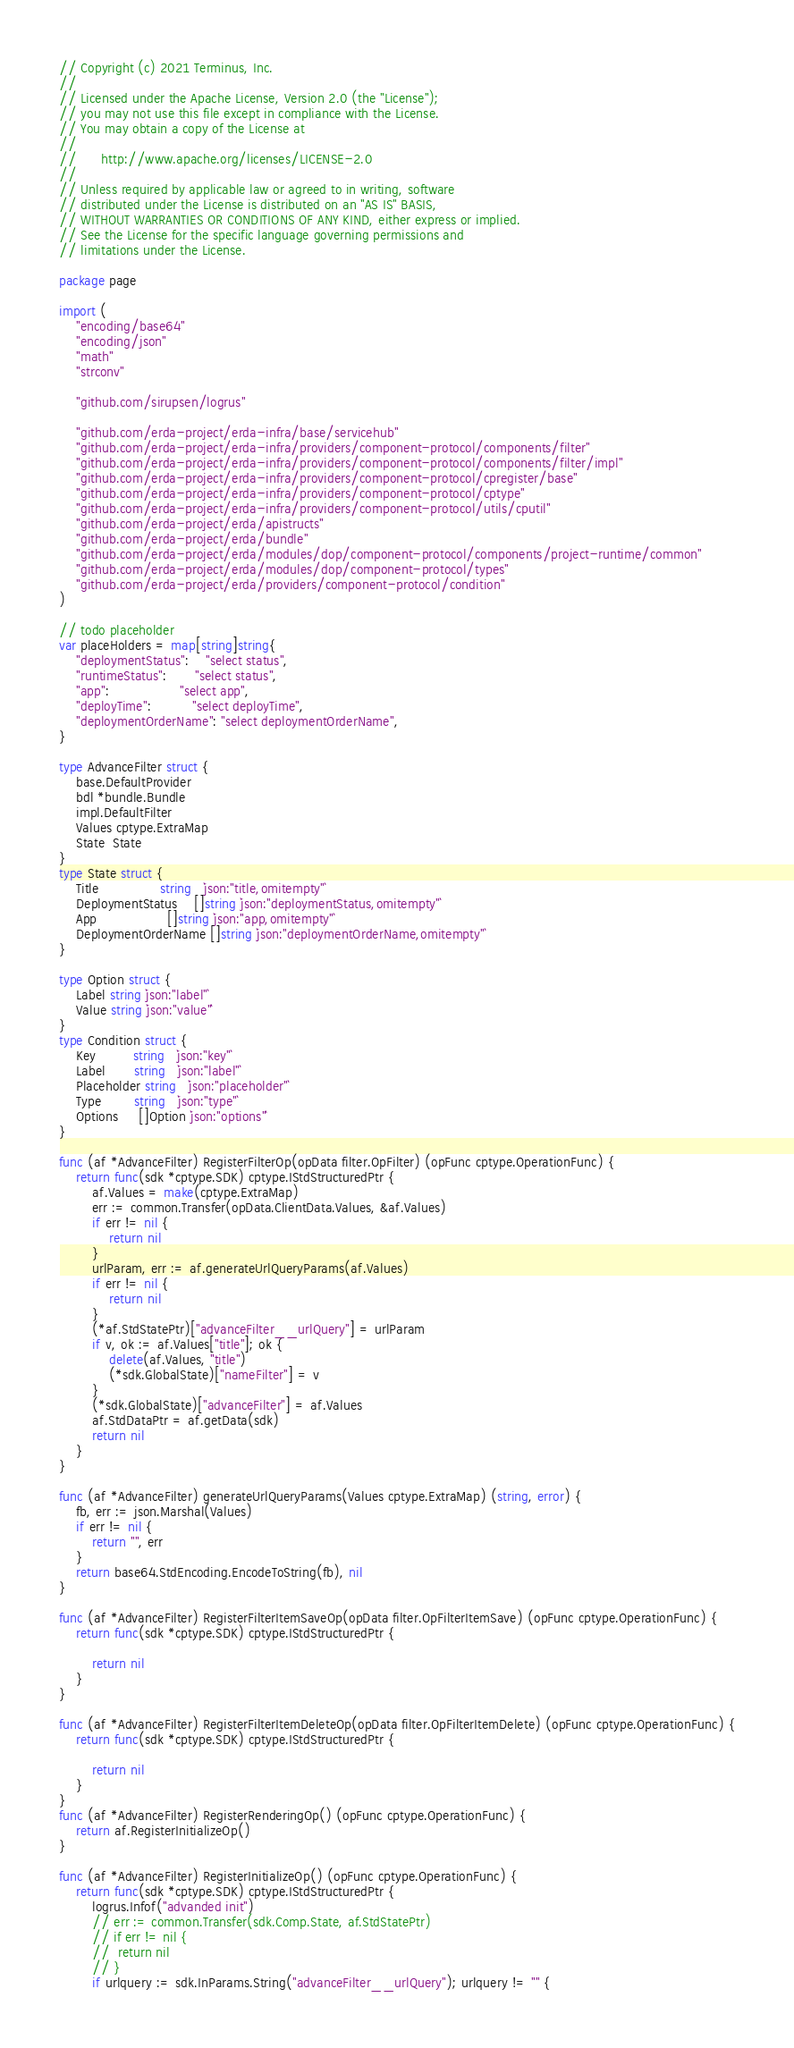<code> <loc_0><loc_0><loc_500><loc_500><_Go_>// Copyright (c) 2021 Terminus, Inc.
//
// Licensed under the Apache License, Version 2.0 (the "License");
// you may not use this file except in compliance with the License.
// You may obtain a copy of the License at
//
//      http://www.apache.org/licenses/LICENSE-2.0
//
// Unless required by applicable law or agreed to in writing, software
// distributed under the License is distributed on an "AS IS" BASIS,
// WITHOUT WARRANTIES OR CONDITIONS OF ANY KIND, either express or implied.
// See the License for the specific language governing permissions and
// limitations under the License.

package page

import (
	"encoding/base64"
	"encoding/json"
	"math"
	"strconv"

	"github.com/sirupsen/logrus"

	"github.com/erda-project/erda-infra/base/servicehub"
	"github.com/erda-project/erda-infra/providers/component-protocol/components/filter"
	"github.com/erda-project/erda-infra/providers/component-protocol/components/filter/impl"
	"github.com/erda-project/erda-infra/providers/component-protocol/cpregister/base"
	"github.com/erda-project/erda-infra/providers/component-protocol/cptype"
	"github.com/erda-project/erda-infra/providers/component-protocol/utils/cputil"
	"github.com/erda-project/erda/apistructs"
	"github.com/erda-project/erda/bundle"
	"github.com/erda-project/erda/modules/dop/component-protocol/components/project-runtime/common"
	"github.com/erda-project/erda/modules/dop/component-protocol/types"
	"github.com/erda-project/erda/providers/component-protocol/condition"
)

// todo placeholder
var placeHolders = map[string]string{
	"deploymentStatus":    "select status",
	"runtimeStatus":       "select status",
	"app":                 "select app",
	"deployTime":          "select deployTime",
	"deploymentOrderName": "select deploymentOrderName",
}

type AdvanceFilter struct {
	base.DefaultProvider
	bdl *bundle.Bundle
	impl.DefaultFilter
	Values cptype.ExtraMap
	State  State
}
type State struct {
	Title               string   `json:"title,omitempty"`
	DeploymentStatus    []string `json:"deploymentStatus,omitempty"`
	App                 []string `json:"app,omitempty"`
	DeploymentOrderName []string `json:"deploymentOrderName,omitempty"`
}

type Option struct {
	Label string `json:"label"`
	Value string `json:"value"`
}
type Condition struct {
	Key         string   `json:"key"`
	Label       string   `json:"label"`
	Placeholder string   `json:"placeholder"`
	Type        string   `json:"type"`
	Options     []Option `json:"options"`
}

func (af *AdvanceFilter) RegisterFilterOp(opData filter.OpFilter) (opFunc cptype.OperationFunc) {
	return func(sdk *cptype.SDK) cptype.IStdStructuredPtr {
		af.Values = make(cptype.ExtraMap)
		err := common.Transfer(opData.ClientData.Values, &af.Values)
		if err != nil {
			return nil
		}
		urlParam, err := af.generateUrlQueryParams(af.Values)
		if err != nil {
			return nil
		}
		(*af.StdStatePtr)["advanceFilter__urlQuery"] = urlParam
		if v, ok := af.Values["title"]; ok {
			delete(af.Values, "title")
			(*sdk.GlobalState)["nameFilter"] = v
		}
		(*sdk.GlobalState)["advanceFilter"] = af.Values
		af.StdDataPtr = af.getData(sdk)
		return nil
	}
}

func (af *AdvanceFilter) generateUrlQueryParams(Values cptype.ExtraMap) (string, error) {
	fb, err := json.Marshal(Values)
	if err != nil {
		return "", err
	}
	return base64.StdEncoding.EncodeToString(fb), nil
}

func (af *AdvanceFilter) RegisterFilterItemSaveOp(opData filter.OpFilterItemSave) (opFunc cptype.OperationFunc) {
	return func(sdk *cptype.SDK) cptype.IStdStructuredPtr {

		return nil
	}
}

func (af *AdvanceFilter) RegisterFilterItemDeleteOp(opData filter.OpFilterItemDelete) (opFunc cptype.OperationFunc) {
	return func(sdk *cptype.SDK) cptype.IStdStructuredPtr {

		return nil
	}
}
func (af *AdvanceFilter) RegisterRenderingOp() (opFunc cptype.OperationFunc) {
	return af.RegisterInitializeOp()
}

func (af *AdvanceFilter) RegisterInitializeOp() (opFunc cptype.OperationFunc) {
	return func(sdk *cptype.SDK) cptype.IStdStructuredPtr {
		logrus.Infof("advanded init")
		// err := common.Transfer(sdk.Comp.State, af.StdStatePtr)
		// if err != nil {
		// 	return nil
		// }
		if urlquery := sdk.InParams.String("advanceFilter__urlQuery"); urlquery != "" {</code> 